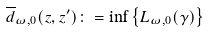Convert formula to latex. <formula><loc_0><loc_0><loc_500><loc_500>\overline { d } _ { \omega , 0 } ( z , z ^ { \prime } ) \colon = \inf \left \{ L _ { \omega , 0 } ( \gamma ) \right \}</formula> 